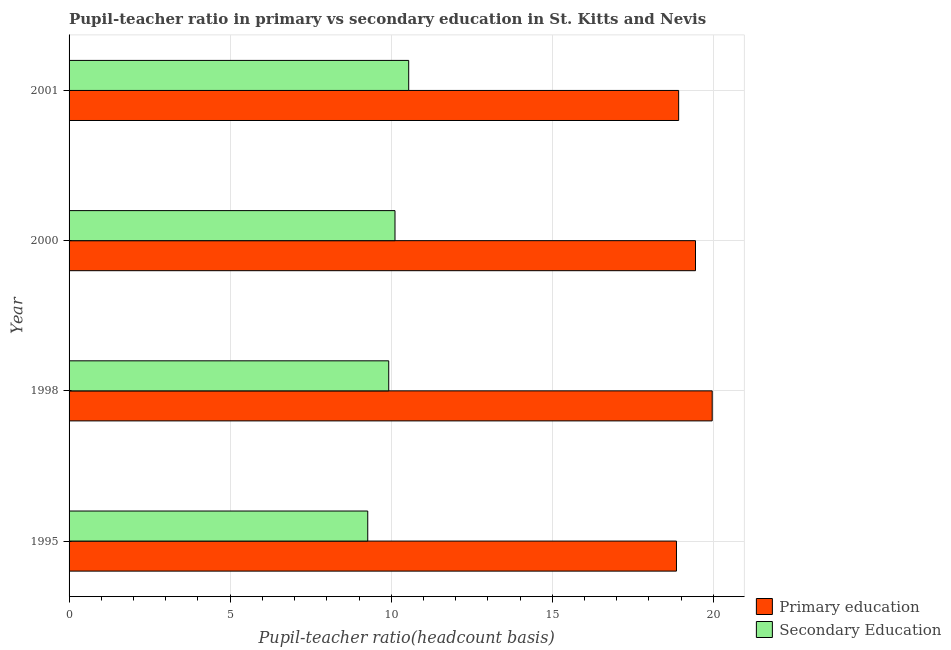How many different coloured bars are there?
Offer a terse response. 2. Are the number of bars per tick equal to the number of legend labels?
Your answer should be very brief. Yes. In how many cases, is the number of bars for a given year not equal to the number of legend labels?
Provide a succinct answer. 0. What is the pupil teacher ratio on secondary education in 2000?
Your response must be concise. 10.12. Across all years, what is the maximum pupil-teacher ratio in primary education?
Provide a short and direct response. 19.96. Across all years, what is the minimum pupil teacher ratio on secondary education?
Provide a short and direct response. 9.27. In which year was the pupil teacher ratio on secondary education maximum?
Your response must be concise. 2001. What is the total pupil teacher ratio on secondary education in the graph?
Offer a very short reply. 39.85. What is the difference between the pupil teacher ratio on secondary education in 1995 and that in 1998?
Your response must be concise. -0.65. What is the difference between the pupil-teacher ratio in primary education in 1998 and the pupil teacher ratio on secondary education in 2001?
Provide a short and direct response. 9.42. What is the average pupil teacher ratio on secondary education per year?
Ensure brevity in your answer.  9.96. In the year 2000, what is the difference between the pupil-teacher ratio in primary education and pupil teacher ratio on secondary education?
Provide a short and direct response. 9.33. What is the ratio of the pupil teacher ratio on secondary education in 1995 to that in 2001?
Your answer should be compact. 0.88. What is the difference between the highest and the second highest pupil teacher ratio on secondary education?
Your response must be concise. 0.43. What is the difference between the highest and the lowest pupil teacher ratio on secondary education?
Make the answer very short. 1.27. In how many years, is the pupil teacher ratio on secondary education greater than the average pupil teacher ratio on secondary education taken over all years?
Give a very brief answer. 2. Is the sum of the pupil-teacher ratio in primary education in 1995 and 1998 greater than the maximum pupil teacher ratio on secondary education across all years?
Your response must be concise. Yes. What does the 1st bar from the top in 2001 represents?
Your response must be concise. Secondary Education. What does the 1st bar from the bottom in 2001 represents?
Your response must be concise. Primary education. How many bars are there?
Provide a succinct answer. 8. Are all the bars in the graph horizontal?
Your answer should be compact. Yes. How many years are there in the graph?
Keep it short and to the point. 4. What is the difference between two consecutive major ticks on the X-axis?
Ensure brevity in your answer.  5. Are the values on the major ticks of X-axis written in scientific E-notation?
Make the answer very short. No. How are the legend labels stacked?
Keep it short and to the point. Vertical. What is the title of the graph?
Your answer should be compact. Pupil-teacher ratio in primary vs secondary education in St. Kitts and Nevis. Does "International Visitors" appear as one of the legend labels in the graph?
Your answer should be very brief. No. What is the label or title of the X-axis?
Your response must be concise. Pupil-teacher ratio(headcount basis). What is the Pupil-teacher ratio(headcount basis) of Primary education in 1995?
Offer a terse response. 18.85. What is the Pupil-teacher ratio(headcount basis) of Secondary Education in 1995?
Provide a succinct answer. 9.27. What is the Pupil-teacher ratio(headcount basis) in Primary education in 1998?
Give a very brief answer. 19.96. What is the Pupil-teacher ratio(headcount basis) of Secondary Education in 1998?
Your answer should be compact. 9.92. What is the Pupil-teacher ratio(headcount basis) of Primary education in 2000?
Your answer should be compact. 19.44. What is the Pupil-teacher ratio(headcount basis) of Secondary Education in 2000?
Your response must be concise. 10.12. What is the Pupil-teacher ratio(headcount basis) of Primary education in 2001?
Your response must be concise. 18.92. What is the Pupil-teacher ratio(headcount basis) of Secondary Education in 2001?
Offer a terse response. 10.54. Across all years, what is the maximum Pupil-teacher ratio(headcount basis) in Primary education?
Keep it short and to the point. 19.96. Across all years, what is the maximum Pupil-teacher ratio(headcount basis) in Secondary Education?
Offer a very short reply. 10.54. Across all years, what is the minimum Pupil-teacher ratio(headcount basis) in Primary education?
Your answer should be compact. 18.85. Across all years, what is the minimum Pupil-teacher ratio(headcount basis) of Secondary Education?
Offer a very short reply. 9.27. What is the total Pupil-teacher ratio(headcount basis) in Primary education in the graph?
Provide a succinct answer. 77.18. What is the total Pupil-teacher ratio(headcount basis) in Secondary Education in the graph?
Make the answer very short. 39.85. What is the difference between the Pupil-teacher ratio(headcount basis) in Primary education in 1995 and that in 1998?
Make the answer very short. -1.11. What is the difference between the Pupil-teacher ratio(headcount basis) of Secondary Education in 1995 and that in 1998?
Provide a succinct answer. -0.65. What is the difference between the Pupil-teacher ratio(headcount basis) in Primary education in 1995 and that in 2000?
Make the answer very short. -0.59. What is the difference between the Pupil-teacher ratio(headcount basis) of Secondary Education in 1995 and that in 2000?
Provide a succinct answer. -0.85. What is the difference between the Pupil-teacher ratio(headcount basis) in Primary education in 1995 and that in 2001?
Give a very brief answer. -0.07. What is the difference between the Pupil-teacher ratio(headcount basis) of Secondary Education in 1995 and that in 2001?
Offer a very short reply. -1.27. What is the difference between the Pupil-teacher ratio(headcount basis) of Primary education in 1998 and that in 2000?
Your answer should be compact. 0.52. What is the difference between the Pupil-teacher ratio(headcount basis) of Secondary Education in 1998 and that in 2000?
Your answer should be compact. -0.19. What is the difference between the Pupil-teacher ratio(headcount basis) in Primary education in 1998 and that in 2001?
Your answer should be very brief. 1.04. What is the difference between the Pupil-teacher ratio(headcount basis) in Secondary Education in 1998 and that in 2001?
Your response must be concise. -0.62. What is the difference between the Pupil-teacher ratio(headcount basis) of Primary education in 2000 and that in 2001?
Your answer should be compact. 0.52. What is the difference between the Pupil-teacher ratio(headcount basis) in Secondary Education in 2000 and that in 2001?
Your answer should be compact. -0.43. What is the difference between the Pupil-teacher ratio(headcount basis) in Primary education in 1995 and the Pupil-teacher ratio(headcount basis) in Secondary Education in 1998?
Offer a very short reply. 8.93. What is the difference between the Pupil-teacher ratio(headcount basis) of Primary education in 1995 and the Pupil-teacher ratio(headcount basis) of Secondary Education in 2000?
Provide a succinct answer. 8.74. What is the difference between the Pupil-teacher ratio(headcount basis) of Primary education in 1995 and the Pupil-teacher ratio(headcount basis) of Secondary Education in 2001?
Make the answer very short. 8.31. What is the difference between the Pupil-teacher ratio(headcount basis) in Primary education in 1998 and the Pupil-teacher ratio(headcount basis) in Secondary Education in 2000?
Ensure brevity in your answer.  9.85. What is the difference between the Pupil-teacher ratio(headcount basis) of Primary education in 1998 and the Pupil-teacher ratio(headcount basis) of Secondary Education in 2001?
Provide a succinct answer. 9.42. What is the difference between the Pupil-teacher ratio(headcount basis) of Primary education in 2000 and the Pupil-teacher ratio(headcount basis) of Secondary Education in 2001?
Offer a terse response. 8.9. What is the average Pupil-teacher ratio(headcount basis) in Primary education per year?
Offer a terse response. 19.3. What is the average Pupil-teacher ratio(headcount basis) in Secondary Education per year?
Provide a succinct answer. 9.96. In the year 1995, what is the difference between the Pupil-teacher ratio(headcount basis) of Primary education and Pupil-teacher ratio(headcount basis) of Secondary Education?
Offer a very short reply. 9.58. In the year 1998, what is the difference between the Pupil-teacher ratio(headcount basis) in Primary education and Pupil-teacher ratio(headcount basis) in Secondary Education?
Ensure brevity in your answer.  10.04. In the year 2000, what is the difference between the Pupil-teacher ratio(headcount basis) of Primary education and Pupil-teacher ratio(headcount basis) of Secondary Education?
Your response must be concise. 9.33. In the year 2001, what is the difference between the Pupil-teacher ratio(headcount basis) in Primary education and Pupil-teacher ratio(headcount basis) in Secondary Education?
Your response must be concise. 8.38. What is the ratio of the Pupil-teacher ratio(headcount basis) in Secondary Education in 1995 to that in 1998?
Keep it short and to the point. 0.93. What is the ratio of the Pupil-teacher ratio(headcount basis) of Primary education in 1995 to that in 2000?
Offer a very short reply. 0.97. What is the ratio of the Pupil-teacher ratio(headcount basis) of Secondary Education in 1995 to that in 2000?
Your response must be concise. 0.92. What is the ratio of the Pupil-teacher ratio(headcount basis) of Primary education in 1995 to that in 2001?
Your response must be concise. 1. What is the ratio of the Pupil-teacher ratio(headcount basis) of Secondary Education in 1995 to that in 2001?
Give a very brief answer. 0.88. What is the ratio of the Pupil-teacher ratio(headcount basis) in Primary education in 1998 to that in 2000?
Provide a short and direct response. 1.03. What is the ratio of the Pupil-teacher ratio(headcount basis) of Secondary Education in 1998 to that in 2000?
Your response must be concise. 0.98. What is the ratio of the Pupil-teacher ratio(headcount basis) in Primary education in 1998 to that in 2001?
Offer a terse response. 1.05. What is the ratio of the Pupil-teacher ratio(headcount basis) in Primary education in 2000 to that in 2001?
Make the answer very short. 1.03. What is the ratio of the Pupil-teacher ratio(headcount basis) in Secondary Education in 2000 to that in 2001?
Make the answer very short. 0.96. What is the difference between the highest and the second highest Pupil-teacher ratio(headcount basis) in Primary education?
Ensure brevity in your answer.  0.52. What is the difference between the highest and the second highest Pupil-teacher ratio(headcount basis) in Secondary Education?
Your answer should be compact. 0.43. What is the difference between the highest and the lowest Pupil-teacher ratio(headcount basis) in Primary education?
Your response must be concise. 1.11. What is the difference between the highest and the lowest Pupil-teacher ratio(headcount basis) of Secondary Education?
Provide a short and direct response. 1.27. 